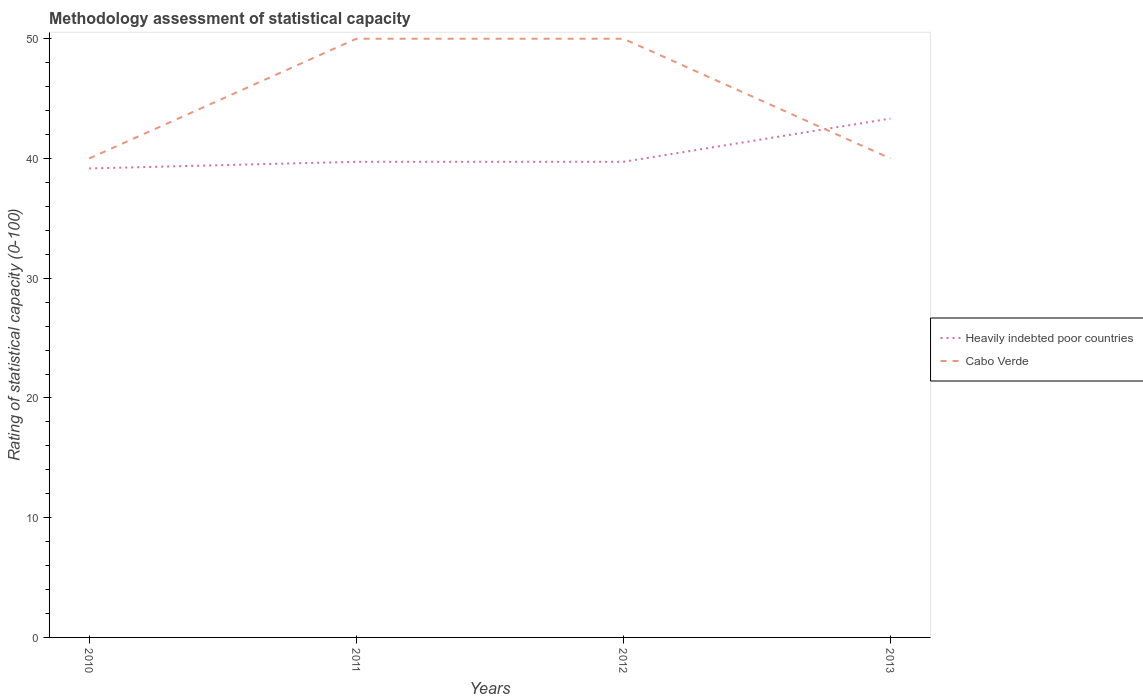Does the line corresponding to Heavily indebted poor countries intersect with the line corresponding to Cabo Verde?
Ensure brevity in your answer.  Yes. Is the number of lines equal to the number of legend labels?
Provide a short and direct response. Yes. Across all years, what is the maximum rating of statistical capacity in Heavily indebted poor countries?
Give a very brief answer. 39.17. What is the total rating of statistical capacity in Cabo Verde in the graph?
Your answer should be very brief. 0. What is the difference between the highest and the second highest rating of statistical capacity in Cabo Verde?
Provide a short and direct response. 10. What is the difference between the highest and the lowest rating of statistical capacity in Cabo Verde?
Your answer should be very brief. 2. Is the rating of statistical capacity in Cabo Verde strictly greater than the rating of statistical capacity in Heavily indebted poor countries over the years?
Your answer should be very brief. No. What is the difference between two consecutive major ticks on the Y-axis?
Your answer should be compact. 10. Are the values on the major ticks of Y-axis written in scientific E-notation?
Provide a succinct answer. No. Where does the legend appear in the graph?
Your response must be concise. Center right. How many legend labels are there?
Offer a terse response. 2. How are the legend labels stacked?
Your answer should be very brief. Vertical. What is the title of the graph?
Provide a short and direct response. Methodology assessment of statistical capacity. Does "East Asia (developing only)" appear as one of the legend labels in the graph?
Make the answer very short. No. What is the label or title of the X-axis?
Your answer should be compact. Years. What is the label or title of the Y-axis?
Give a very brief answer. Rating of statistical capacity (0-100). What is the Rating of statistical capacity (0-100) in Heavily indebted poor countries in 2010?
Keep it short and to the point. 39.17. What is the Rating of statistical capacity (0-100) in Cabo Verde in 2010?
Offer a terse response. 40. What is the Rating of statistical capacity (0-100) in Heavily indebted poor countries in 2011?
Your answer should be very brief. 39.72. What is the Rating of statistical capacity (0-100) in Heavily indebted poor countries in 2012?
Provide a succinct answer. 39.72. What is the Rating of statistical capacity (0-100) in Cabo Verde in 2012?
Your response must be concise. 50. What is the Rating of statistical capacity (0-100) in Heavily indebted poor countries in 2013?
Your answer should be very brief. 43.33. Across all years, what is the maximum Rating of statistical capacity (0-100) in Heavily indebted poor countries?
Ensure brevity in your answer.  43.33. Across all years, what is the maximum Rating of statistical capacity (0-100) in Cabo Verde?
Your response must be concise. 50. Across all years, what is the minimum Rating of statistical capacity (0-100) of Heavily indebted poor countries?
Ensure brevity in your answer.  39.17. Across all years, what is the minimum Rating of statistical capacity (0-100) of Cabo Verde?
Your answer should be very brief. 40. What is the total Rating of statistical capacity (0-100) in Heavily indebted poor countries in the graph?
Your response must be concise. 161.94. What is the total Rating of statistical capacity (0-100) of Cabo Verde in the graph?
Offer a terse response. 180. What is the difference between the Rating of statistical capacity (0-100) in Heavily indebted poor countries in 2010 and that in 2011?
Provide a succinct answer. -0.56. What is the difference between the Rating of statistical capacity (0-100) in Heavily indebted poor countries in 2010 and that in 2012?
Make the answer very short. -0.56. What is the difference between the Rating of statistical capacity (0-100) of Heavily indebted poor countries in 2010 and that in 2013?
Offer a very short reply. -4.17. What is the difference between the Rating of statistical capacity (0-100) of Heavily indebted poor countries in 2011 and that in 2012?
Make the answer very short. 0. What is the difference between the Rating of statistical capacity (0-100) in Cabo Verde in 2011 and that in 2012?
Make the answer very short. 0. What is the difference between the Rating of statistical capacity (0-100) of Heavily indebted poor countries in 2011 and that in 2013?
Give a very brief answer. -3.61. What is the difference between the Rating of statistical capacity (0-100) in Cabo Verde in 2011 and that in 2013?
Give a very brief answer. 10. What is the difference between the Rating of statistical capacity (0-100) in Heavily indebted poor countries in 2012 and that in 2013?
Your response must be concise. -3.61. What is the difference between the Rating of statistical capacity (0-100) in Cabo Verde in 2012 and that in 2013?
Your answer should be very brief. 10. What is the difference between the Rating of statistical capacity (0-100) of Heavily indebted poor countries in 2010 and the Rating of statistical capacity (0-100) of Cabo Verde in 2011?
Provide a succinct answer. -10.83. What is the difference between the Rating of statistical capacity (0-100) in Heavily indebted poor countries in 2010 and the Rating of statistical capacity (0-100) in Cabo Verde in 2012?
Make the answer very short. -10.83. What is the difference between the Rating of statistical capacity (0-100) of Heavily indebted poor countries in 2010 and the Rating of statistical capacity (0-100) of Cabo Verde in 2013?
Your answer should be very brief. -0.83. What is the difference between the Rating of statistical capacity (0-100) in Heavily indebted poor countries in 2011 and the Rating of statistical capacity (0-100) in Cabo Verde in 2012?
Make the answer very short. -10.28. What is the difference between the Rating of statistical capacity (0-100) of Heavily indebted poor countries in 2011 and the Rating of statistical capacity (0-100) of Cabo Verde in 2013?
Ensure brevity in your answer.  -0.28. What is the difference between the Rating of statistical capacity (0-100) of Heavily indebted poor countries in 2012 and the Rating of statistical capacity (0-100) of Cabo Verde in 2013?
Your response must be concise. -0.28. What is the average Rating of statistical capacity (0-100) in Heavily indebted poor countries per year?
Ensure brevity in your answer.  40.49. What is the average Rating of statistical capacity (0-100) in Cabo Verde per year?
Keep it short and to the point. 45. In the year 2010, what is the difference between the Rating of statistical capacity (0-100) of Heavily indebted poor countries and Rating of statistical capacity (0-100) of Cabo Verde?
Keep it short and to the point. -0.83. In the year 2011, what is the difference between the Rating of statistical capacity (0-100) of Heavily indebted poor countries and Rating of statistical capacity (0-100) of Cabo Verde?
Your answer should be very brief. -10.28. In the year 2012, what is the difference between the Rating of statistical capacity (0-100) of Heavily indebted poor countries and Rating of statistical capacity (0-100) of Cabo Verde?
Give a very brief answer. -10.28. What is the ratio of the Rating of statistical capacity (0-100) in Heavily indebted poor countries in 2010 to that in 2011?
Provide a succinct answer. 0.99. What is the ratio of the Rating of statistical capacity (0-100) of Cabo Verde in 2010 to that in 2011?
Offer a very short reply. 0.8. What is the ratio of the Rating of statistical capacity (0-100) of Heavily indebted poor countries in 2010 to that in 2012?
Make the answer very short. 0.99. What is the ratio of the Rating of statistical capacity (0-100) in Cabo Verde in 2010 to that in 2012?
Your answer should be compact. 0.8. What is the ratio of the Rating of statistical capacity (0-100) of Heavily indebted poor countries in 2010 to that in 2013?
Make the answer very short. 0.9. What is the ratio of the Rating of statistical capacity (0-100) in Cabo Verde in 2010 to that in 2013?
Offer a very short reply. 1. What is the ratio of the Rating of statistical capacity (0-100) in Heavily indebted poor countries in 2011 to that in 2012?
Your answer should be compact. 1. What is the ratio of the Rating of statistical capacity (0-100) in Heavily indebted poor countries in 2012 to that in 2013?
Make the answer very short. 0.92. What is the difference between the highest and the second highest Rating of statistical capacity (0-100) in Heavily indebted poor countries?
Your response must be concise. 3.61. What is the difference between the highest and the lowest Rating of statistical capacity (0-100) in Heavily indebted poor countries?
Your answer should be very brief. 4.17. 